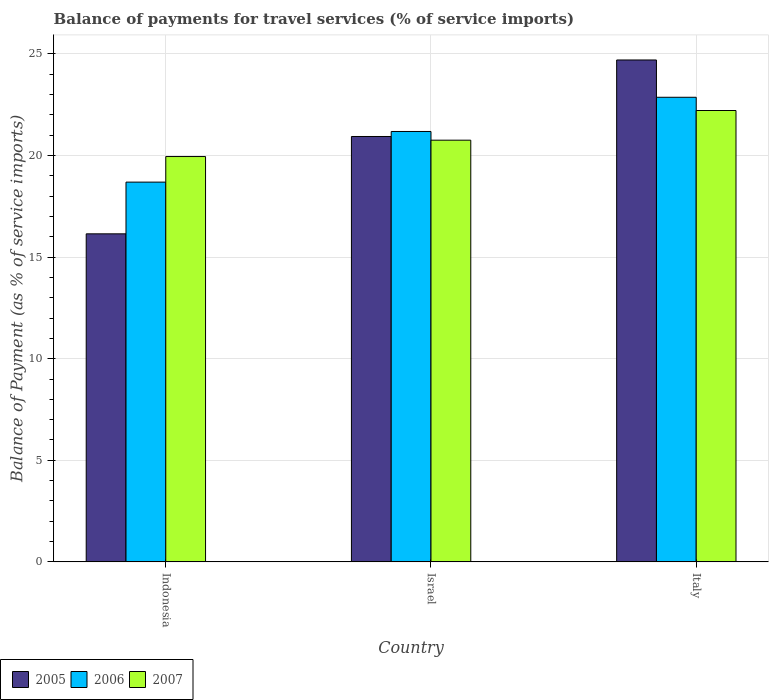How many different coloured bars are there?
Offer a very short reply. 3. Are the number of bars per tick equal to the number of legend labels?
Your answer should be very brief. Yes. Are the number of bars on each tick of the X-axis equal?
Your answer should be very brief. Yes. How many bars are there on the 3rd tick from the right?
Keep it short and to the point. 3. What is the label of the 2nd group of bars from the left?
Give a very brief answer. Israel. What is the balance of payments for travel services in 2007 in Italy?
Keep it short and to the point. 22.22. Across all countries, what is the maximum balance of payments for travel services in 2007?
Ensure brevity in your answer.  22.22. Across all countries, what is the minimum balance of payments for travel services in 2007?
Offer a terse response. 19.95. In which country was the balance of payments for travel services in 2007 minimum?
Your answer should be compact. Indonesia. What is the total balance of payments for travel services in 2007 in the graph?
Your answer should be compact. 62.93. What is the difference between the balance of payments for travel services in 2006 in Israel and that in Italy?
Your answer should be very brief. -1.68. What is the difference between the balance of payments for travel services in 2005 in Israel and the balance of payments for travel services in 2006 in Indonesia?
Offer a terse response. 2.25. What is the average balance of payments for travel services in 2007 per country?
Your answer should be compact. 20.98. What is the difference between the balance of payments for travel services of/in 2005 and balance of payments for travel services of/in 2006 in Indonesia?
Make the answer very short. -2.55. In how many countries, is the balance of payments for travel services in 2007 greater than 4 %?
Give a very brief answer. 3. What is the ratio of the balance of payments for travel services in 2005 in Israel to that in Italy?
Provide a short and direct response. 0.85. Is the difference between the balance of payments for travel services in 2005 in Indonesia and Italy greater than the difference between the balance of payments for travel services in 2006 in Indonesia and Italy?
Your response must be concise. No. What is the difference between the highest and the second highest balance of payments for travel services in 2007?
Provide a succinct answer. -0.81. What is the difference between the highest and the lowest balance of payments for travel services in 2007?
Your response must be concise. 2.27. In how many countries, is the balance of payments for travel services in 2007 greater than the average balance of payments for travel services in 2007 taken over all countries?
Your response must be concise. 1. What does the 3rd bar from the left in Italy represents?
Keep it short and to the point. 2007. What does the 3rd bar from the right in Italy represents?
Offer a very short reply. 2005. Is it the case that in every country, the sum of the balance of payments for travel services in 2005 and balance of payments for travel services in 2006 is greater than the balance of payments for travel services in 2007?
Provide a short and direct response. Yes. How many bars are there?
Ensure brevity in your answer.  9. Are all the bars in the graph horizontal?
Your answer should be very brief. No. How are the legend labels stacked?
Give a very brief answer. Horizontal. What is the title of the graph?
Offer a terse response. Balance of payments for travel services (% of service imports). Does "1961" appear as one of the legend labels in the graph?
Your response must be concise. No. What is the label or title of the X-axis?
Give a very brief answer. Country. What is the label or title of the Y-axis?
Your answer should be very brief. Balance of Payment (as % of service imports). What is the Balance of Payment (as % of service imports) in 2005 in Indonesia?
Give a very brief answer. 16.15. What is the Balance of Payment (as % of service imports) of 2006 in Indonesia?
Provide a succinct answer. 18.69. What is the Balance of Payment (as % of service imports) in 2007 in Indonesia?
Your answer should be very brief. 19.95. What is the Balance of Payment (as % of service imports) of 2005 in Israel?
Give a very brief answer. 20.94. What is the Balance of Payment (as % of service imports) of 2006 in Israel?
Give a very brief answer. 21.19. What is the Balance of Payment (as % of service imports) of 2007 in Israel?
Make the answer very short. 20.76. What is the Balance of Payment (as % of service imports) of 2005 in Italy?
Your response must be concise. 24.71. What is the Balance of Payment (as % of service imports) of 2006 in Italy?
Ensure brevity in your answer.  22.87. What is the Balance of Payment (as % of service imports) in 2007 in Italy?
Give a very brief answer. 22.22. Across all countries, what is the maximum Balance of Payment (as % of service imports) of 2005?
Provide a succinct answer. 24.71. Across all countries, what is the maximum Balance of Payment (as % of service imports) in 2006?
Your answer should be compact. 22.87. Across all countries, what is the maximum Balance of Payment (as % of service imports) of 2007?
Make the answer very short. 22.22. Across all countries, what is the minimum Balance of Payment (as % of service imports) of 2005?
Ensure brevity in your answer.  16.15. Across all countries, what is the minimum Balance of Payment (as % of service imports) in 2006?
Your answer should be compact. 18.69. Across all countries, what is the minimum Balance of Payment (as % of service imports) in 2007?
Provide a succinct answer. 19.95. What is the total Balance of Payment (as % of service imports) in 2005 in the graph?
Your response must be concise. 61.79. What is the total Balance of Payment (as % of service imports) of 2006 in the graph?
Give a very brief answer. 62.75. What is the total Balance of Payment (as % of service imports) in 2007 in the graph?
Your answer should be compact. 62.93. What is the difference between the Balance of Payment (as % of service imports) in 2005 in Indonesia and that in Israel?
Your answer should be very brief. -4.79. What is the difference between the Balance of Payment (as % of service imports) in 2006 in Indonesia and that in Israel?
Your answer should be compact. -2.49. What is the difference between the Balance of Payment (as % of service imports) of 2007 in Indonesia and that in Israel?
Your answer should be compact. -0.81. What is the difference between the Balance of Payment (as % of service imports) in 2005 in Indonesia and that in Italy?
Provide a succinct answer. -8.56. What is the difference between the Balance of Payment (as % of service imports) in 2006 in Indonesia and that in Italy?
Your answer should be very brief. -4.18. What is the difference between the Balance of Payment (as % of service imports) in 2007 in Indonesia and that in Italy?
Your answer should be compact. -2.27. What is the difference between the Balance of Payment (as % of service imports) in 2005 in Israel and that in Italy?
Ensure brevity in your answer.  -3.77. What is the difference between the Balance of Payment (as % of service imports) of 2006 in Israel and that in Italy?
Offer a terse response. -1.68. What is the difference between the Balance of Payment (as % of service imports) of 2007 in Israel and that in Italy?
Provide a succinct answer. -1.46. What is the difference between the Balance of Payment (as % of service imports) of 2005 in Indonesia and the Balance of Payment (as % of service imports) of 2006 in Israel?
Provide a short and direct response. -5.04. What is the difference between the Balance of Payment (as % of service imports) of 2005 in Indonesia and the Balance of Payment (as % of service imports) of 2007 in Israel?
Your answer should be very brief. -4.61. What is the difference between the Balance of Payment (as % of service imports) of 2006 in Indonesia and the Balance of Payment (as % of service imports) of 2007 in Israel?
Offer a terse response. -2.06. What is the difference between the Balance of Payment (as % of service imports) of 2005 in Indonesia and the Balance of Payment (as % of service imports) of 2006 in Italy?
Give a very brief answer. -6.72. What is the difference between the Balance of Payment (as % of service imports) in 2005 in Indonesia and the Balance of Payment (as % of service imports) in 2007 in Italy?
Your response must be concise. -6.07. What is the difference between the Balance of Payment (as % of service imports) of 2006 in Indonesia and the Balance of Payment (as % of service imports) of 2007 in Italy?
Give a very brief answer. -3.52. What is the difference between the Balance of Payment (as % of service imports) in 2005 in Israel and the Balance of Payment (as % of service imports) in 2006 in Italy?
Ensure brevity in your answer.  -1.93. What is the difference between the Balance of Payment (as % of service imports) of 2005 in Israel and the Balance of Payment (as % of service imports) of 2007 in Italy?
Keep it short and to the point. -1.28. What is the difference between the Balance of Payment (as % of service imports) of 2006 in Israel and the Balance of Payment (as % of service imports) of 2007 in Italy?
Give a very brief answer. -1.03. What is the average Balance of Payment (as % of service imports) of 2005 per country?
Your answer should be compact. 20.6. What is the average Balance of Payment (as % of service imports) of 2006 per country?
Your answer should be compact. 20.92. What is the average Balance of Payment (as % of service imports) in 2007 per country?
Your response must be concise. 20.98. What is the difference between the Balance of Payment (as % of service imports) of 2005 and Balance of Payment (as % of service imports) of 2006 in Indonesia?
Provide a succinct answer. -2.55. What is the difference between the Balance of Payment (as % of service imports) of 2005 and Balance of Payment (as % of service imports) of 2007 in Indonesia?
Keep it short and to the point. -3.8. What is the difference between the Balance of Payment (as % of service imports) of 2006 and Balance of Payment (as % of service imports) of 2007 in Indonesia?
Give a very brief answer. -1.26. What is the difference between the Balance of Payment (as % of service imports) in 2005 and Balance of Payment (as % of service imports) in 2006 in Israel?
Offer a terse response. -0.25. What is the difference between the Balance of Payment (as % of service imports) in 2005 and Balance of Payment (as % of service imports) in 2007 in Israel?
Give a very brief answer. 0.18. What is the difference between the Balance of Payment (as % of service imports) in 2006 and Balance of Payment (as % of service imports) in 2007 in Israel?
Provide a succinct answer. 0.43. What is the difference between the Balance of Payment (as % of service imports) of 2005 and Balance of Payment (as % of service imports) of 2006 in Italy?
Make the answer very short. 1.84. What is the difference between the Balance of Payment (as % of service imports) of 2005 and Balance of Payment (as % of service imports) of 2007 in Italy?
Give a very brief answer. 2.49. What is the difference between the Balance of Payment (as % of service imports) of 2006 and Balance of Payment (as % of service imports) of 2007 in Italy?
Provide a succinct answer. 0.65. What is the ratio of the Balance of Payment (as % of service imports) in 2005 in Indonesia to that in Israel?
Give a very brief answer. 0.77. What is the ratio of the Balance of Payment (as % of service imports) of 2006 in Indonesia to that in Israel?
Your answer should be very brief. 0.88. What is the ratio of the Balance of Payment (as % of service imports) of 2007 in Indonesia to that in Israel?
Ensure brevity in your answer.  0.96. What is the ratio of the Balance of Payment (as % of service imports) in 2005 in Indonesia to that in Italy?
Offer a terse response. 0.65. What is the ratio of the Balance of Payment (as % of service imports) in 2006 in Indonesia to that in Italy?
Offer a very short reply. 0.82. What is the ratio of the Balance of Payment (as % of service imports) in 2007 in Indonesia to that in Italy?
Make the answer very short. 0.9. What is the ratio of the Balance of Payment (as % of service imports) in 2005 in Israel to that in Italy?
Offer a terse response. 0.85. What is the ratio of the Balance of Payment (as % of service imports) of 2006 in Israel to that in Italy?
Offer a very short reply. 0.93. What is the ratio of the Balance of Payment (as % of service imports) of 2007 in Israel to that in Italy?
Offer a terse response. 0.93. What is the difference between the highest and the second highest Balance of Payment (as % of service imports) in 2005?
Offer a very short reply. 3.77. What is the difference between the highest and the second highest Balance of Payment (as % of service imports) in 2006?
Offer a terse response. 1.68. What is the difference between the highest and the second highest Balance of Payment (as % of service imports) in 2007?
Keep it short and to the point. 1.46. What is the difference between the highest and the lowest Balance of Payment (as % of service imports) of 2005?
Give a very brief answer. 8.56. What is the difference between the highest and the lowest Balance of Payment (as % of service imports) of 2006?
Give a very brief answer. 4.18. What is the difference between the highest and the lowest Balance of Payment (as % of service imports) of 2007?
Your answer should be very brief. 2.27. 